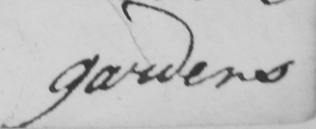What text is written in this handwritten line? gardens 